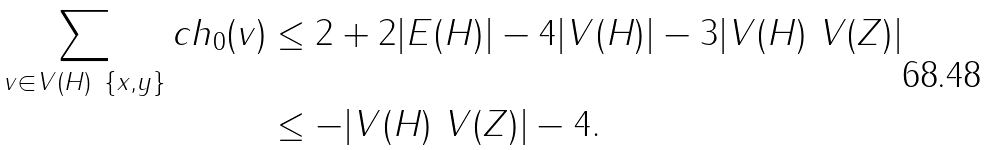<formula> <loc_0><loc_0><loc_500><loc_500>\sum _ { v \in V ( H ) \ \{ x , y \} } c h _ { 0 } ( v ) & \leq 2 + 2 | E ( H ) | - 4 | V ( H ) | - 3 | V ( H ) \ V ( Z ) | \\ & \leq - | V ( H ) \ V ( Z ) | - 4 .</formula> 